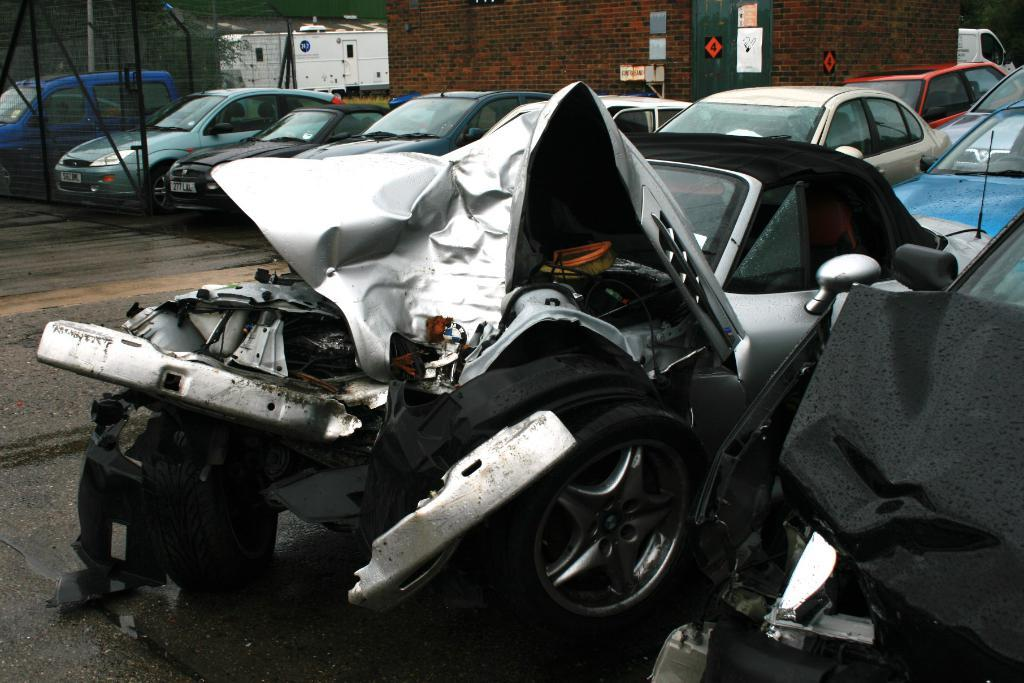What can be seen in the foreground of the image? There are damaged cars in the foreground of the image. What else is visible in the image? There are vehicles and a wall in the background of the image. Are there any other structures or objects in the background? Yes, there is fencing and a building in the background of the image. What type of jar is being used to express regret in the image? There is no jar or expression of regret present in the image. 